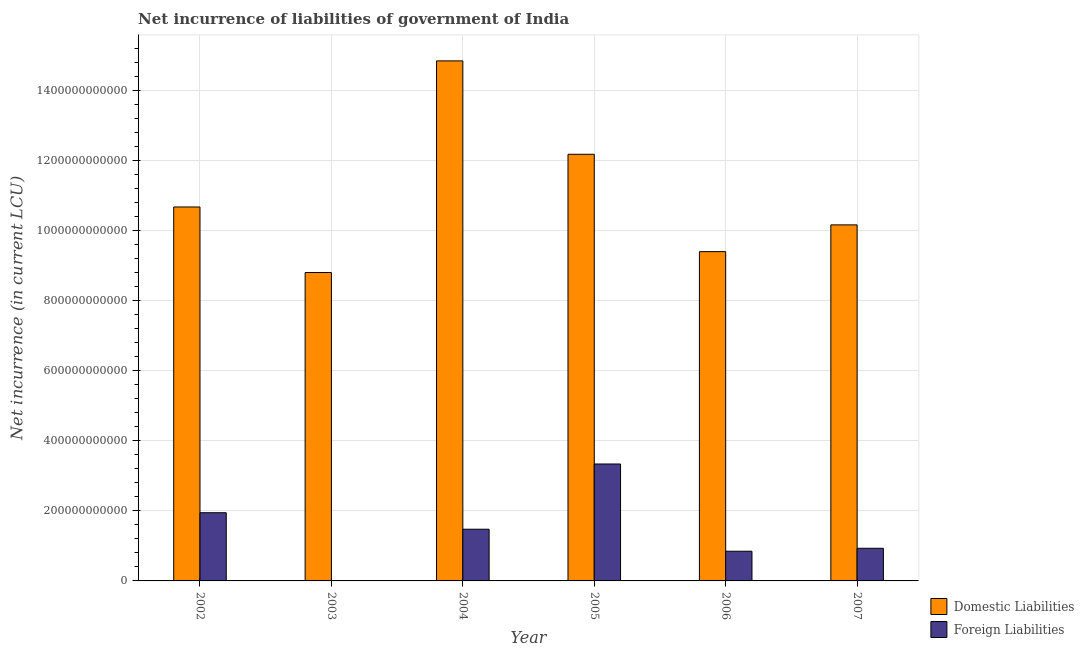How many different coloured bars are there?
Ensure brevity in your answer.  2. What is the net incurrence of foreign liabilities in 2006?
Provide a short and direct response. 8.47e+1. Across all years, what is the maximum net incurrence of domestic liabilities?
Give a very brief answer. 1.48e+12. Across all years, what is the minimum net incurrence of domestic liabilities?
Keep it short and to the point. 8.80e+11. What is the total net incurrence of domestic liabilities in the graph?
Offer a terse response. 6.60e+12. What is the difference between the net incurrence of domestic liabilities in 2003 and that in 2006?
Keep it short and to the point. -5.96e+1. What is the difference between the net incurrence of domestic liabilities in 2002 and the net incurrence of foreign liabilities in 2007?
Your answer should be compact. 5.11e+1. What is the average net incurrence of domestic liabilities per year?
Keep it short and to the point. 1.10e+12. In how many years, is the net incurrence of domestic liabilities greater than 1040000000000 LCU?
Make the answer very short. 3. What is the ratio of the net incurrence of foreign liabilities in 2005 to that in 2006?
Offer a terse response. 3.94. What is the difference between the highest and the second highest net incurrence of domestic liabilities?
Give a very brief answer. 2.67e+11. What is the difference between the highest and the lowest net incurrence of foreign liabilities?
Your response must be concise. 3.34e+11. In how many years, is the net incurrence of domestic liabilities greater than the average net incurrence of domestic liabilities taken over all years?
Make the answer very short. 2. Is the sum of the net incurrence of domestic liabilities in 2002 and 2006 greater than the maximum net incurrence of foreign liabilities across all years?
Ensure brevity in your answer.  Yes. Are all the bars in the graph horizontal?
Provide a short and direct response. No. What is the difference between two consecutive major ticks on the Y-axis?
Give a very brief answer. 2.00e+11. Does the graph contain any zero values?
Give a very brief answer. Yes. Does the graph contain grids?
Your answer should be compact. Yes. Where does the legend appear in the graph?
Offer a terse response. Bottom right. How are the legend labels stacked?
Your answer should be compact. Vertical. What is the title of the graph?
Ensure brevity in your answer.  Net incurrence of liabilities of government of India. What is the label or title of the Y-axis?
Ensure brevity in your answer.  Net incurrence (in current LCU). What is the Net incurrence (in current LCU) in Domestic Liabilities in 2002?
Keep it short and to the point. 1.07e+12. What is the Net incurrence (in current LCU) in Foreign Liabilities in 2002?
Offer a terse response. 1.95e+11. What is the Net incurrence (in current LCU) in Domestic Liabilities in 2003?
Your answer should be compact. 8.80e+11. What is the Net incurrence (in current LCU) of Foreign Liabilities in 2003?
Provide a short and direct response. 0. What is the Net incurrence (in current LCU) of Domestic Liabilities in 2004?
Keep it short and to the point. 1.48e+12. What is the Net incurrence (in current LCU) of Foreign Liabilities in 2004?
Your response must be concise. 1.48e+11. What is the Net incurrence (in current LCU) in Domestic Liabilities in 2005?
Make the answer very short. 1.22e+12. What is the Net incurrence (in current LCU) of Foreign Liabilities in 2005?
Ensure brevity in your answer.  3.34e+11. What is the Net incurrence (in current LCU) of Domestic Liabilities in 2006?
Your answer should be compact. 9.40e+11. What is the Net incurrence (in current LCU) of Foreign Liabilities in 2006?
Offer a very short reply. 8.47e+1. What is the Net incurrence (in current LCU) of Domestic Liabilities in 2007?
Offer a very short reply. 1.02e+12. What is the Net incurrence (in current LCU) of Foreign Liabilities in 2007?
Ensure brevity in your answer.  9.32e+1. Across all years, what is the maximum Net incurrence (in current LCU) of Domestic Liabilities?
Provide a short and direct response. 1.48e+12. Across all years, what is the maximum Net incurrence (in current LCU) of Foreign Liabilities?
Give a very brief answer. 3.34e+11. Across all years, what is the minimum Net incurrence (in current LCU) in Domestic Liabilities?
Provide a succinct answer. 8.80e+11. What is the total Net incurrence (in current LCU) in Domestic Liabilities in the graph?
Your answer should be very brief. 6.60e+12. What is the total Net incurrence (in current LCU) in Foreign Liabilities in the graph?
Ensure brevity in your answer.  8.54e+11. What is the difference between the Net incurrence (in current LCU) of Domestic Liabilities in 2002 and that in 2003?
Your answer should be compact. 1.87e+11. What is the difference between the Net incurrence (in current LCU) in Domestic Liabilities in 2002 and that in 2004?
Make the answer very short. -4.17e+11. What is the difference between the Net incurrence (in current LCU) of Foreign Liabilities in 2002 and that in 2004?
Keep it short and to the point. 4.71e+1. What is the difference between the Net incurrence (in current LCU) of Domestic Liabilities in 2002 and that in 2005?
Give a very brief answer. -1.50e+11. What is the difference between the Net incurrence (in current LCU) in Foreign Liabilities in 2002 and that in 2005?
Offer a very short reply. -1.39e+11. What is the difference between the Net incurrence (in current LCU) of Domestic Liabilities in 2002 and that in 2006?
Offer a very short reply. 1.27e+11. What is the difference between the Net incurrence (in current LCU) in Foreign Liabilities in 2002 and that in 2006?
Offer a terse response. 1.10e+11. What is the difference between the Net incurrence (in current LCU) in Domestic Liabilities in 2002 and that in 2007?
Offer a very short reply. 5.11e+1. What is the difference between the Net incurrence (in current LCU) in Foreign Liabilities in 2002 and that in 2007?
Offer a very short reply. 1.01e+11. What is the difference between the Net incurrence (in current LCU) in Domestic Liabilities in 2003 and that in 2004?
Your response must be concise. -6.04e+11. What is the difference between the Net incurrence (in current LCU) in Domestic Liabilities in 2003 and that in 2005?
Your answer should be very brief. -3.37e+11. What is the difference between the Net incurrence (in current LCU) in Domestic Liabilities in 2003 and that in 2006?
Your answer should be compact. -5.96e+1. What is the difference between the Net incurrence (in current LCU) of Domestic Liabilities in 2003 and that in 2007?
Offer a very short reply. -1.36e+11. What is the difference between the Net incurrence (in current LCU) in Domestic Liabilities in 2004 and that in 2005?
Offer a very short reply. 2.67e+11. What is the difference between the Net incurrence (in current LCU) of Foreign Liabilities in 2004 and that in 2005?
Keep it short and to the point. -1.86e+11. What is the difference between the Net incurrence (in current LCU) in Domestic Liabilities in 2004 and that in 2006?
Your answer should be compact. 5.44e+11. What is the difference between the Net incurrence (in current LCU) in Foreign Liabilities in 2004 and that in 2006?
Provide a short and direct response. 6.28e+1. What is the difference between the Net incurrence (in current LCU) in Domestic Liabilities in 2004 and that in 2007?
Make the answer very short. 4.68e+11. What is the difference between the Net incurrence (in current LCU) of Foreign Liabilities in 2004 and that in 2007?
Your response must be concise. 5.44e+1. What is the difference between the Net incurrence (in current LCU) of Domestic Liabilities in 2005 and that in 2006?
Your answer should be compact. 2.78e+11. What is the difference between the Net incurrence (in current LCU) in Foreign Liabilities in 2005 and that in 2006?
Ensure brevity in your answer.  2.49e+11. What is the difference between the Net incurrence (in current LCU) in Domestic Liabilities in 2005 and that in 2007?
Provide a succinct answer. 2.01e+11. What is the difference between the Net incurrence (in current LCU) of Foreign Liabilities in 2005 and that in 2007?
Offer a terse response. 2.40e+11. What is the difference between the Net incurrence (in current LCU) of Domestic Liabilities in 2006 and that in 2007?
Offer a terse response. -7.64e+1. What is the difference between the Net incurrence (in current LCU) of Foreign Liabilities in 2006 and that in 2007?
Ensure brevity in your answer.  -8.43e+09. What is the difference between the Net incurrence (in current LCU) of Domestic Liabilities in 2002 and the Net incurrence (in current LCU) of Foreign Liabilities in 2004?
Your response must be concise. 9.20e+11. What is the difference between the Net incurrence (in current LCU) of Domestic Liabilities in 2002 and the Net incurrence (in current LCU) of Foreign Liabilities in 2005?
Your answer should be very brief. 7.33e+11. What is the difference between the Net incurrence (in current LCU) of Domestic Liabilities in 2002 and the Net incurrence (in current LCU) of Foreign Liabilities in 2006?
Your response must be concise. 9.82e+11. What is the difference between the Net incurrence (in current LCU) of Domestic Liabilities in 2002 and the Net incurrence (in current LCU) of Foreign Liabilities in 2007?
Your answer should be compact. 9.74e+11. What is the difference between the Net incurrence (in current LCU) of Domestic Liabilities in 2003 and the Net incurrence (in current LCU) of Foreign Liabilities in 2004?
Offer a terse response. 7.33e+11. What is the difference between the Net incurrence (in current LCU) in Domestic Liabilities in 2003 and the Net incurrence (in current LCU) in Foreign Liabilities in 2005?
Provide a succinct answer. 5.46e+11. What is the difference between the Net incurrence (in current LCU) in Domestic Liabilities in 2003 and the Net incurrence (in current LCU) in Foreign Liabilities in 2006?
Keep it short and to the point. 7.95e+11. What is the difference between the Net incurrence (in current LCU) in Domestic Liabilities in 2003 and the Net incurrence (in current LCU) in Foreign Liabilities in 2007?
Offer a very short reply. 7.87e+11. What is the difference between the Net incurrence (in current LCU) of Domestic Liabilities in 2004 and the Net incurrence (in current LCU) of Foreign Liabilities in 2005?
Offer a terse response. 1.15e+12. What is the difference between the Net incurrence (in current LCU) in Domestic Liabilities in 2004 and the Net incurrence (in current LCU) in Foreign Liabilities in 2006?
Your response must be concise. 1.40e+12. What is the difference between the Net incurrence (in current LCU) of Domestic Liabilities in 2004 and the Net incurrence (in current LCU) of Foreign Liabilities in 2007?
Your answer should be very brief. 1.39e+12. What is the difference between the Net incurrence (in current LCU) in Domestic Liabilities in 2005 and the Net incurrence (in current LCU) in Foreign Liabilities in 2006?
Offer a very short reply. 1.13e+12. What is the difference between the Net incurrence (in current LCU) in Domestic Liabilities in 2005 and the Net incurrence (in current LCU) in Foreign Liabilities in 2007?
Your response must be concise. 1.12e+12. What is the difference between the Net incurrence (in current LCU) in Domestic Liabilities in 2006 and the Net incurrence (in current LCU) in Foreign Liabilities in 2007?
Keep it short and to the point. 8.46e+11. What is the average Net incurrence (in current LCU) in Domestic Liabilities per year?
Your answer should be very brief. 1.10e+12. What is the average Net incurrence (in current LCU) in Foreign Liabilities per year?
Provide a short and direct response. 1.42e+11. In the year 2002, what is the difference between the Net incurrence (in current LCU) in Domestic Liabilities and Net incurrence (in current LCU) in Foreign Liabilities?
Your response must be concise. 8.73e+11. In the year 2004, what is the difference between the Net incurrence (in current LCU) in Domestic Liabilities and Net incurrence (in current LCU) in Foreign Liabilities?
Offer a very short reply. 1.34e+12. In the year 2005, what is the difference between the Net incurrence (in current LCU) of Domestic Liabilities and Net incurrence (in current LCU) of Foreign Liabilities?
Your answer should be very brief. 8.84e+11. In the year 2006, what is the difference between the Net incurrence (in current LCU) in Domestic Liabilities and Net incurrence (in current LCU) in Foreign Liabilities?
Ensure brevity in your answer.  8.55e+11. In the year 2007, what is the difference between the Net incurrence (in current LCU) of Domestic Liabilities and Net incurrence (in current LCU) of Foreign Liabilities?
Offer a terse response. 9.23e+11. What is the ratio of the Net incurrence (in current LCU) of Domestic Liabilities in 2002 to that in 2003?
Ensure brevity in your answer.  1.21. What is the ratio of the Net incurrence (in current LCU) of Domestic Liabilities in 2002 to that in 2004?
Keep it short and to the point. 0.72. What is the ratio of the Net incurrence (in current LCU) of Foreign Liabilities in 2002 to that in 2004?
Your answer should be compact. 1.32. What is the ratio of the Net incurrence (in current LCU) in Domestic Liabilities in 2002 to that in 2005?
Your answer should be very brief. 0.88. What is the ratio of the Net incurrence (in current LCU) of Foreign Liabilities in 2002 to that in 2005?
Give a very brief answer. 0.58. What is the ratio of the Net incurrence (in current LCU) in Domestic Liabilities in 2002 to that in 2006?
Ensure brevity in your answer.  1.14. What is the ratio of the Net incurrence (in current LCU) in Foreign Liabilities in 2002 to that in 2006?
Your response must be concise. 2.3. What is the ratio of the Net incurrence (in current LCU) in Domestic Liabilities in 2002 to that in 2007?
Give a very brief answer. 1.05. What is the ratio of the Net incurrence (in current LCU) in Foreign Liabilities in 2002 to that in 2007?
Provide a succinct answer. 2.09. What is the ratio of the Net incurrence (in current LCU) of Domestic Liabilities in 2003 to that in 2004?
Provide a short and direct response. 0.59. What is the ratio of the Net incurrence (in current LCU) in Domestic Liabilities in 2003 to that in 2005?
Keep it short and to the point. 0.72. What is the ratio of the Net incurrence (in current LCU) in Domestic Liabilities in 2003 to that in 2006?
Keep it short and to the point. 0.94. What is the ratio of the Net incurrence (in current LCU) of Domestic Liabilities in 2003 to that in 2007?
Your response must be concise. 0.87. What is the ratio of the Net incurrence (in current LCU) in Domestic Liabilities in 2004 to that in 2005?
Your response must be concise. 1.22. What is the ratio of the Net incurrence (in current LCU) in Foreign Liabilities in 2004 to that in 2005?
Your answer should be compact. 0.44. What is the ratio of the Net incurrence (in current LCU) in Domestic Liabilities in 2004 to that in 2006?
Make the answer very short. 1.58. What is the ratio of the Net incurrence (in current LCU) of Foreign Liabilities in 2004 to that in 2006?
Offer a very short reply. 1.74. What is the ratio of the Net incurrence (in current LCU) in Domestic Liabilities in 2004 to that in 2007?
Provide a succinct answer. 1.46. What is the ratio of the Net incurrence (in current LCU) in Foreign Liabilities in 2004 to that in 2007?
Make the answer very short. 1.58. What is the ratio of the Net incurrence (in current LCU) of Domestic Liabilities in 2005 to that in 2006?
Provide a short and direct response. 1.3. What is the ratio of the Net incurrence (in current LCU) in Foreign Liabilities in 2005 to that in 2006?
Provide a succinct answer. 3.94. What is the ratio of the Net incurrence (in current LCU) in Domestic Liabilities in 2005 to that in 2007?
Keep it short and to the point. 1.2. What is the ratio of the Net incurrence (in current LCU) of Foreign Liabilities in 2005 to that in 2007?
Provide a short and direct response. 3.58. What is the ratio of the Net incurrence (in current LCU) of Domestic Liabilities in 2006 to that in 2007?
Keep it short and to the point. 0.92. What is the ratio of the Net incurrence (in current LCU) in Foreign Liabilities in 2006 to that in 2007?
Your answer should be compact. 0.91. What is the difference between the highest and the second highest Net incurrence (in current LCU) of Domestic Liabilities?
Keep it short and to the point. 2.67e+11. What is the difference between the highest and the second highest Net incurrence (in current LCU) of Foreign Liabilities?
Provide a short and direct response. 1.39e+11. What is the difference between the highest and the lowest Net incurrence (in current LCU) of Domestic Liabilities?
Offer a terse response. 6.04e+11. What is the difference between the highest and the lowest Net incurrence (in current LCU) in Foreign Liabilities?
Your answer should be compact. 3.34e+11. 